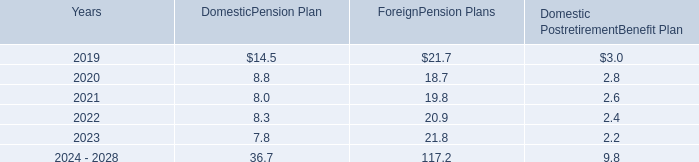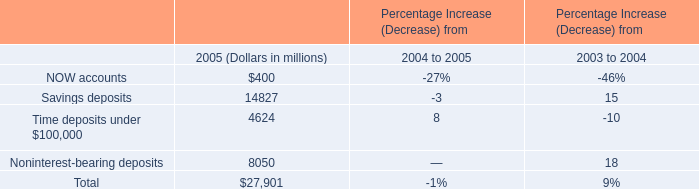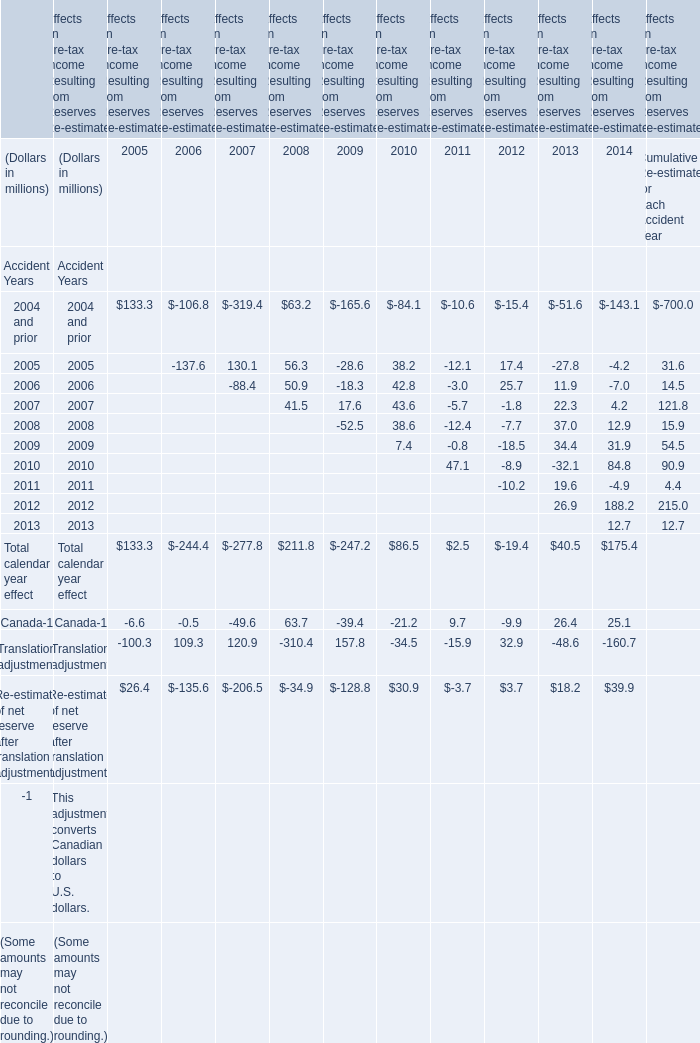What is the sum of the Canada-1 in the years where Total calendar year effect greater than 150? (in million) 
Computations: (63.7 + 25.1)
Answer: 88.8. 